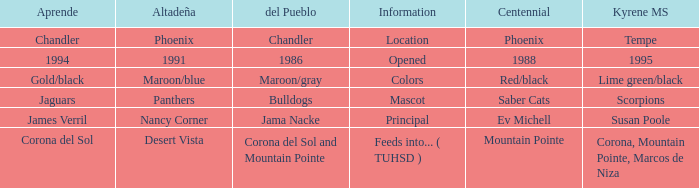Which Centennial has a del Pueblo of 1986? 1988.0. 